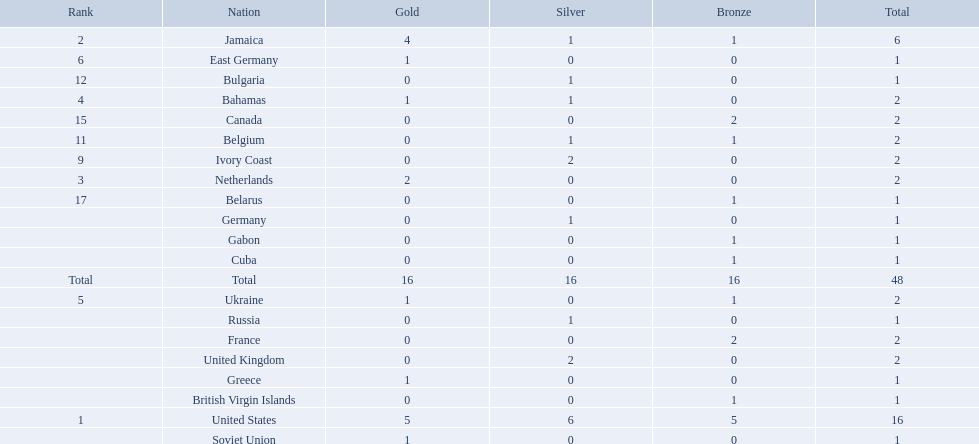Which nations took home at least one gold medal in the 60 metres competition? United States, Jamaica, Netherlands, Bahamas, Ukraine, East Germany, Greece, Soviet Union. Of these nations, which one won the most gold medals? United States. 